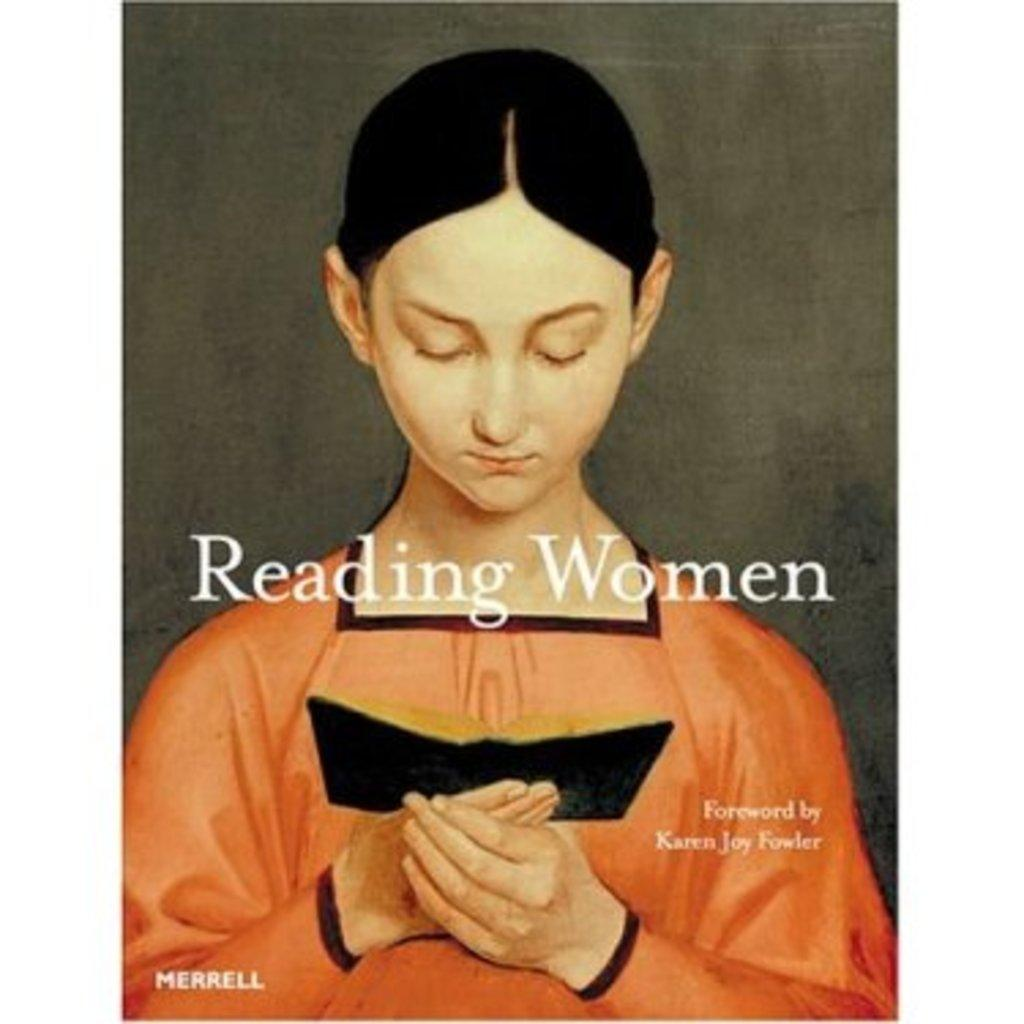Who is present in the image? There is a woman in the image. What is the woman holding in the image? The woman is holding a book. Can you describe the text visible in the image? The text is visible on the book that the woman is holding. What is the color of the background in the image? The background of the image is grey. What type of underwear is the woman wearing in the image? There is no information about the woman's underwear in the image, as it is not visible or mentioned in the provided facts. 